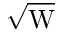Convert formula to latex. <formula><loc_0><loc_0><loc_500><loc_500>\sqrt { W }</formula> 